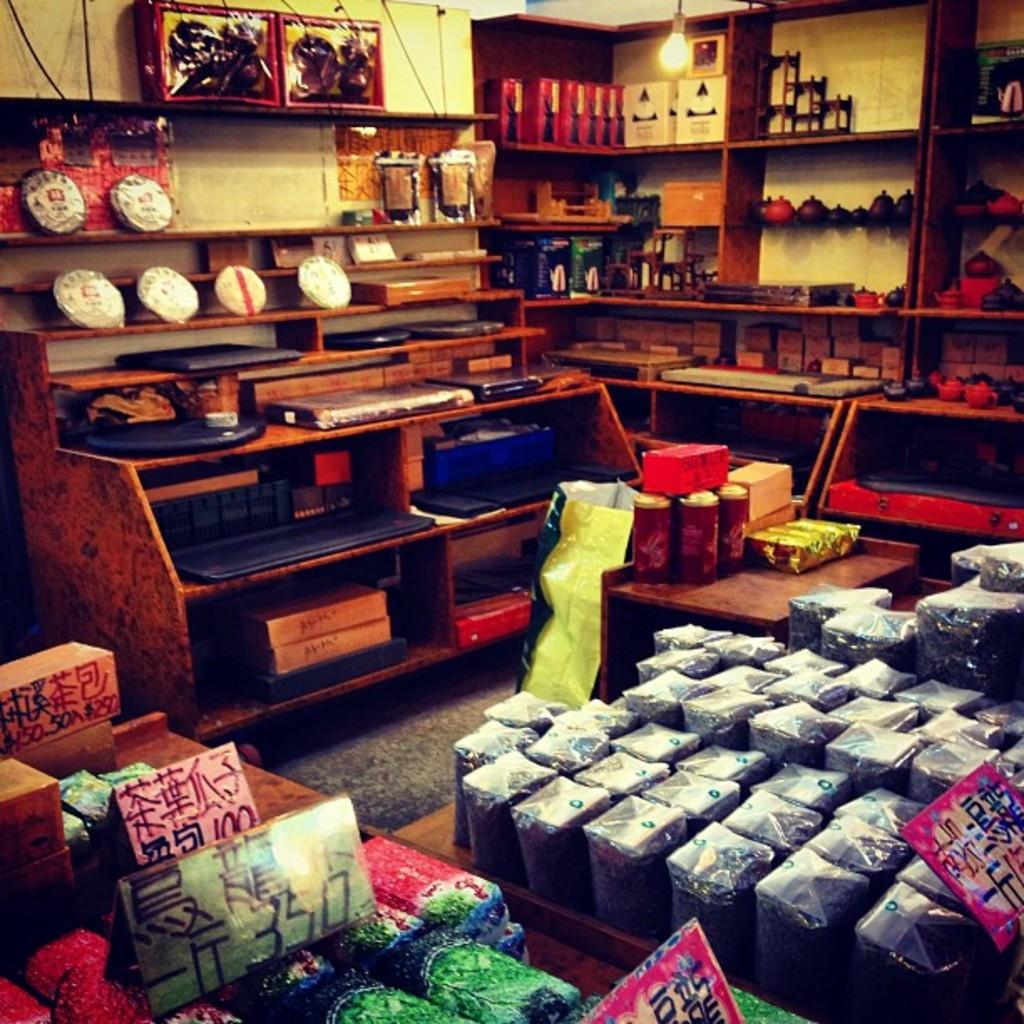<image>
Provide a brief description of the given image. Snacks are arranged in a store with a sign that reads 350. 